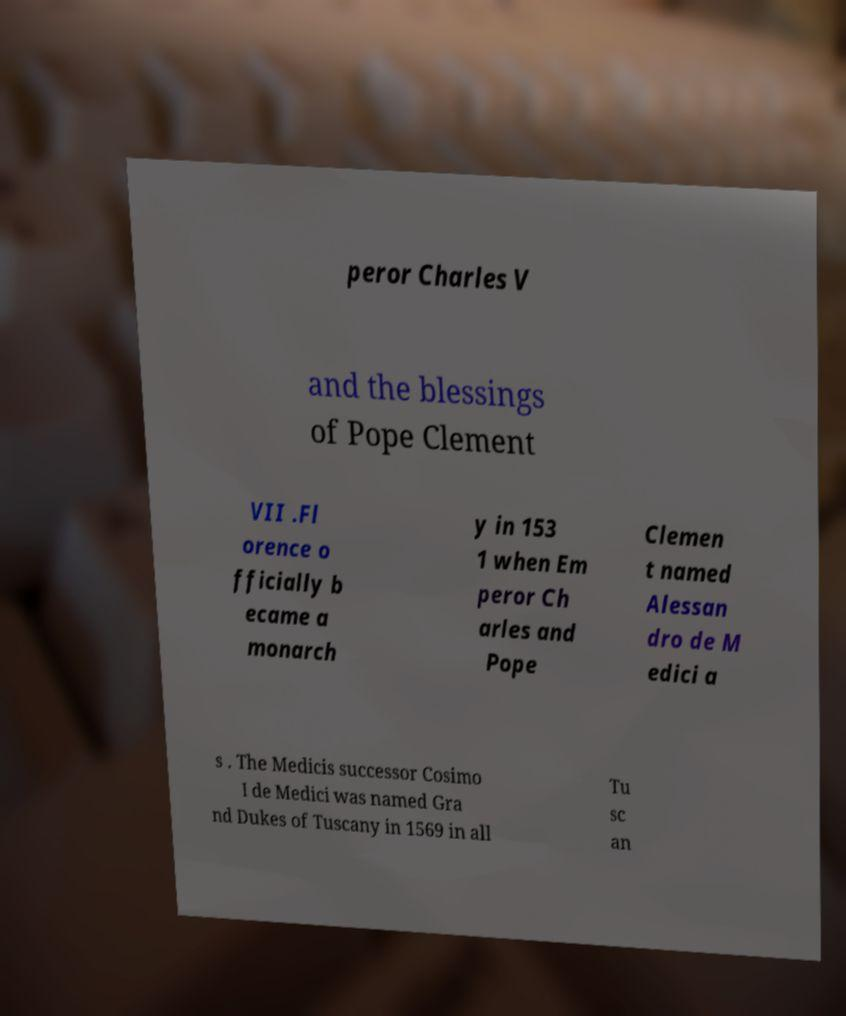Please identify and transcribe the text found in this image. peror Charles V and the blessings of Pope Clement VII .Fl orence o fficially b ecame a monarch y in 153 1 when Em peror Ch arles and Pope Clemen t named Alessan dro de M edici a s . The Medicis successor Cosimo I de Medici was named Gra nd Dukes of Tuscany in 1569 in all Tu sc an 